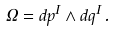Convert formula to latex. <formula><loc_0><loc_0><loc_500><loc_500>\Omega = d p ^ { I } \wedge d q ^ { I } \, .</formula> 